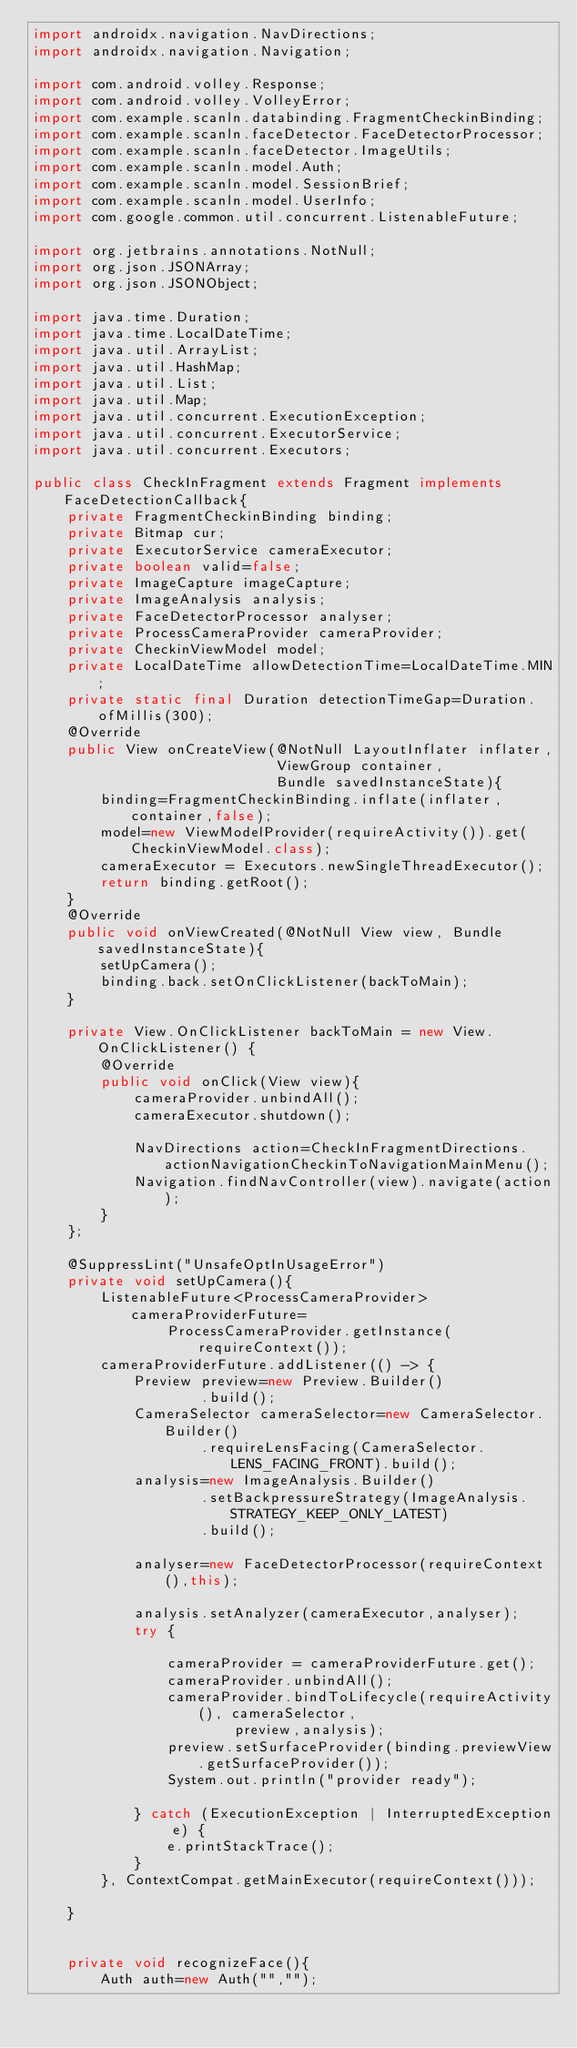Convert code to text. <code><loc_0><loc_0><loc_500><loc_500><_Java_>import androidx.navigation.NavDirections;
import androidx.navigation.Navigation;

import com.android.volley.Response;
import com.android.volley.VolleyError;
import com.example.scanln.databinding.FragmentCheckinBinding;
import com.example.scanln.faceDetector.FaceDetectorProcessor;
import com.example.scanln.faceDetector.ImageUtils;
import com.example.scanln.model.Auth;
import com.example.scanln.model.SessionBrief;
import com.example.scanln.model.UserInfo;
import com.google.common.util.concurrent.ListenableFuture;

import org.jetbrains.annotations.NotNull;
import org.json.JSONArray;
import org.json.JSONObject;

import java.time.Duration;
import java.time.LocalDateTime;
import java.util.ArrayList;
import java.util.HashMap;
import java.util.List;
import java.util.Map;
import java.util.concurrent.ExecutionException;
import java.util.concurrent.ExecutorService;
import java.util.concurrent.Executors;

public class CheckInFragment extends Fragment implements FaceDetectionCallback{
    private FragmentCheckinBinding binding;
    private Bitmap cur;
    private ExecutorService cameraExecutor;
    private boolean valid=false;
    private ImageCapture imageCapture;
    private ImageAnalysis analysis;
    private FaceDetectorProcessor analyser;
    private ProcessCameraProvider cameraProvider;
    private CheckinViewModel model;
    private LocalDateTime allowDetectionTime=LocalDateTime.MIN;
    private static final Duration detectionTimeGap=Duration.ofMillis(300);
    @Override
    public View onCreateView(@NotNull LayoutInflater inflater,
                             ViewGroup container,
                             Bundle savedInstanceState){
        binding=FragmentCheckinBinding.inflate(inflater,container,false);
        model=new ViewModelProvider(requireActivity()).get(CheckinViewModel.class);
        cameraExecutor = Executors.newSingleThreadExecutor();
        return binding.getRoot();
    }
    @Override
    public void onViewCreated(@NotNull View view, Bundle savedInstanceState){
        setUpCamera();
        binding.back.setOnClickListener(backToMain);
    }

    private View.OnClickListener backToMain = new View.OnClickListener() {
        @Override
        public void onClick(View view){
            cameraProvider.unbindAll();
            cameraExecutor.shutdown();

            NavDirections action=CheckInFragmentDirections.actionNavigationCheckinToNavigationMainMenu();
            Navigation.findNavController(view).navigate(action);
        }
    };

    @SuppressLint("UnsafeOptInUsageError")
    private void setUpCamera(){
        ListenableFuture<ProcessCameraProvider> cameraProviderFuture=
                ProcessCameraProvider.getInstance(requireContext());
        cameraProviderFuture.addListener(() -> {
            Preview preview=new Preview.Builder()
                    .build();
            CameraSelector cameraSelector=new CameraSelector.Builder()
                    .requireLensFacing(CameraSelector.LENS_FACING_FRONT).build();
            analysis=new ImageAnalysis.Builder()
                    .setBackpressureStrategy(ImageAnalysis.STRATEGY_KEEP_ONLY_LATEST)
                    .build();

            analyser=new FaceDetectorProcessor(requireContext(),this);

            analysis.setAnalyzer(cameraExecutor,analyser);
            try {

                cameraProvider = cameraProviderFuture.get();
                cameraProvider.unbindAll();
                cameraProvider.bindToLifecycle(requireActivity(), cameraSelector,
                        preview,analysis);
                preview.setSurfaceProvider(binding.previewView.getSurfaceProvider());
                System.out.println("provider ready");

            } catch (ExecutionException | InterruptedException e) {
                e.printStackTrace();
            }
        }, ContextCompat.getMainExecutor(requireContext()));

    }


    private void recognizeFace(){
        Auth auth=new Auth("","");</code> 